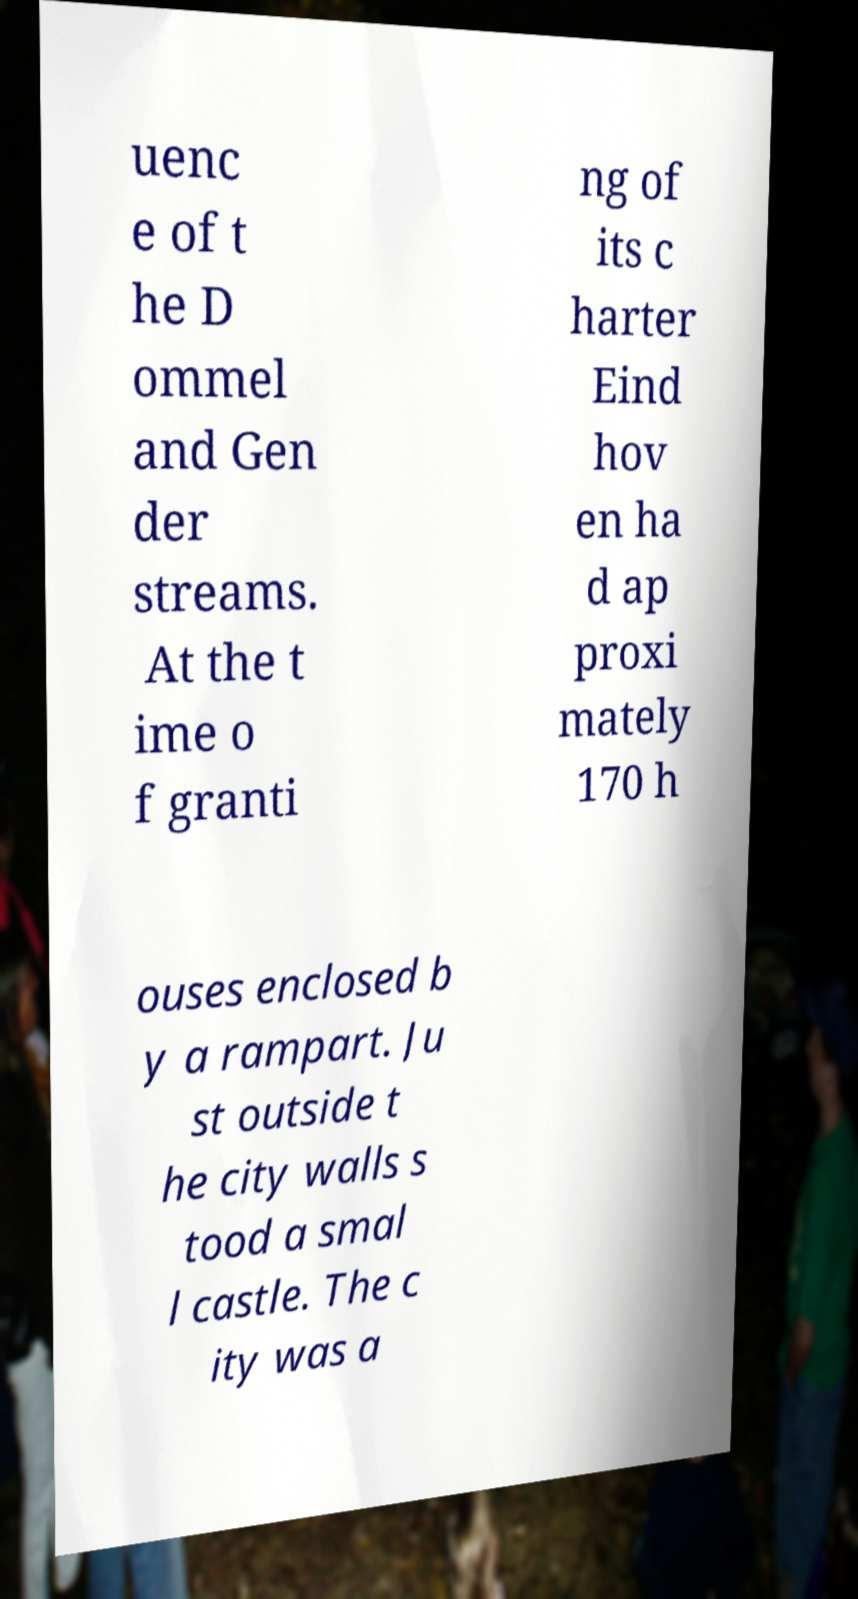Could you assist in decoding the text presented in this image and type it out clearly? uenc e of t he D ommel and Gen der streams. At the t ime o f granti ng of its c harter Eind hov en ha d ap proxi mately 170 h ouses enclosed b y a rampart. Ju st outside t he city walls s tood a smal l castle. The c ity was a 